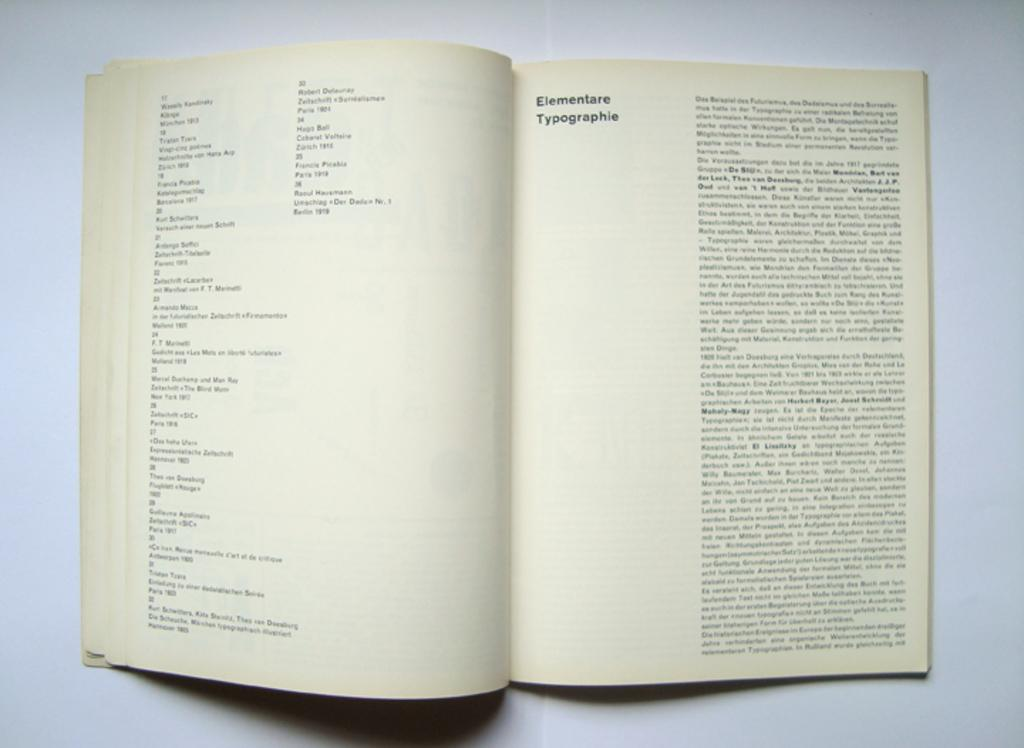Provide a one-sentence caption for the provided image. A book opened to a page about elementare typographie. 